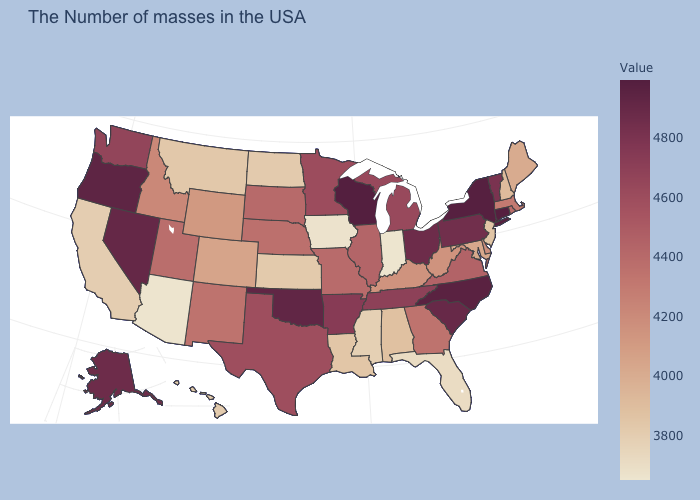Does New Jersey have the highest value in the Northeast?
Quick response, please. No. Which states hav the highest value in the Northeast?
Give a very brief answer. Connecticut. Among the states that border Michigan , does Wisconsin have the lowest value?
Short answer required. No. Among the states that border New Jersey , does Pennsylvania have the highest value?
Keep it brief. No. 